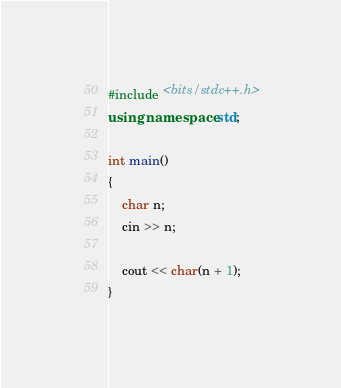<code> <loc_0><loc_0><loc_500><loc_500><_C++_>#include <bits/stdc++.h>
using namespace std;

int main()
{
    char n;
    cin >> n;

    cout << char(n + 1);
}
</code> 